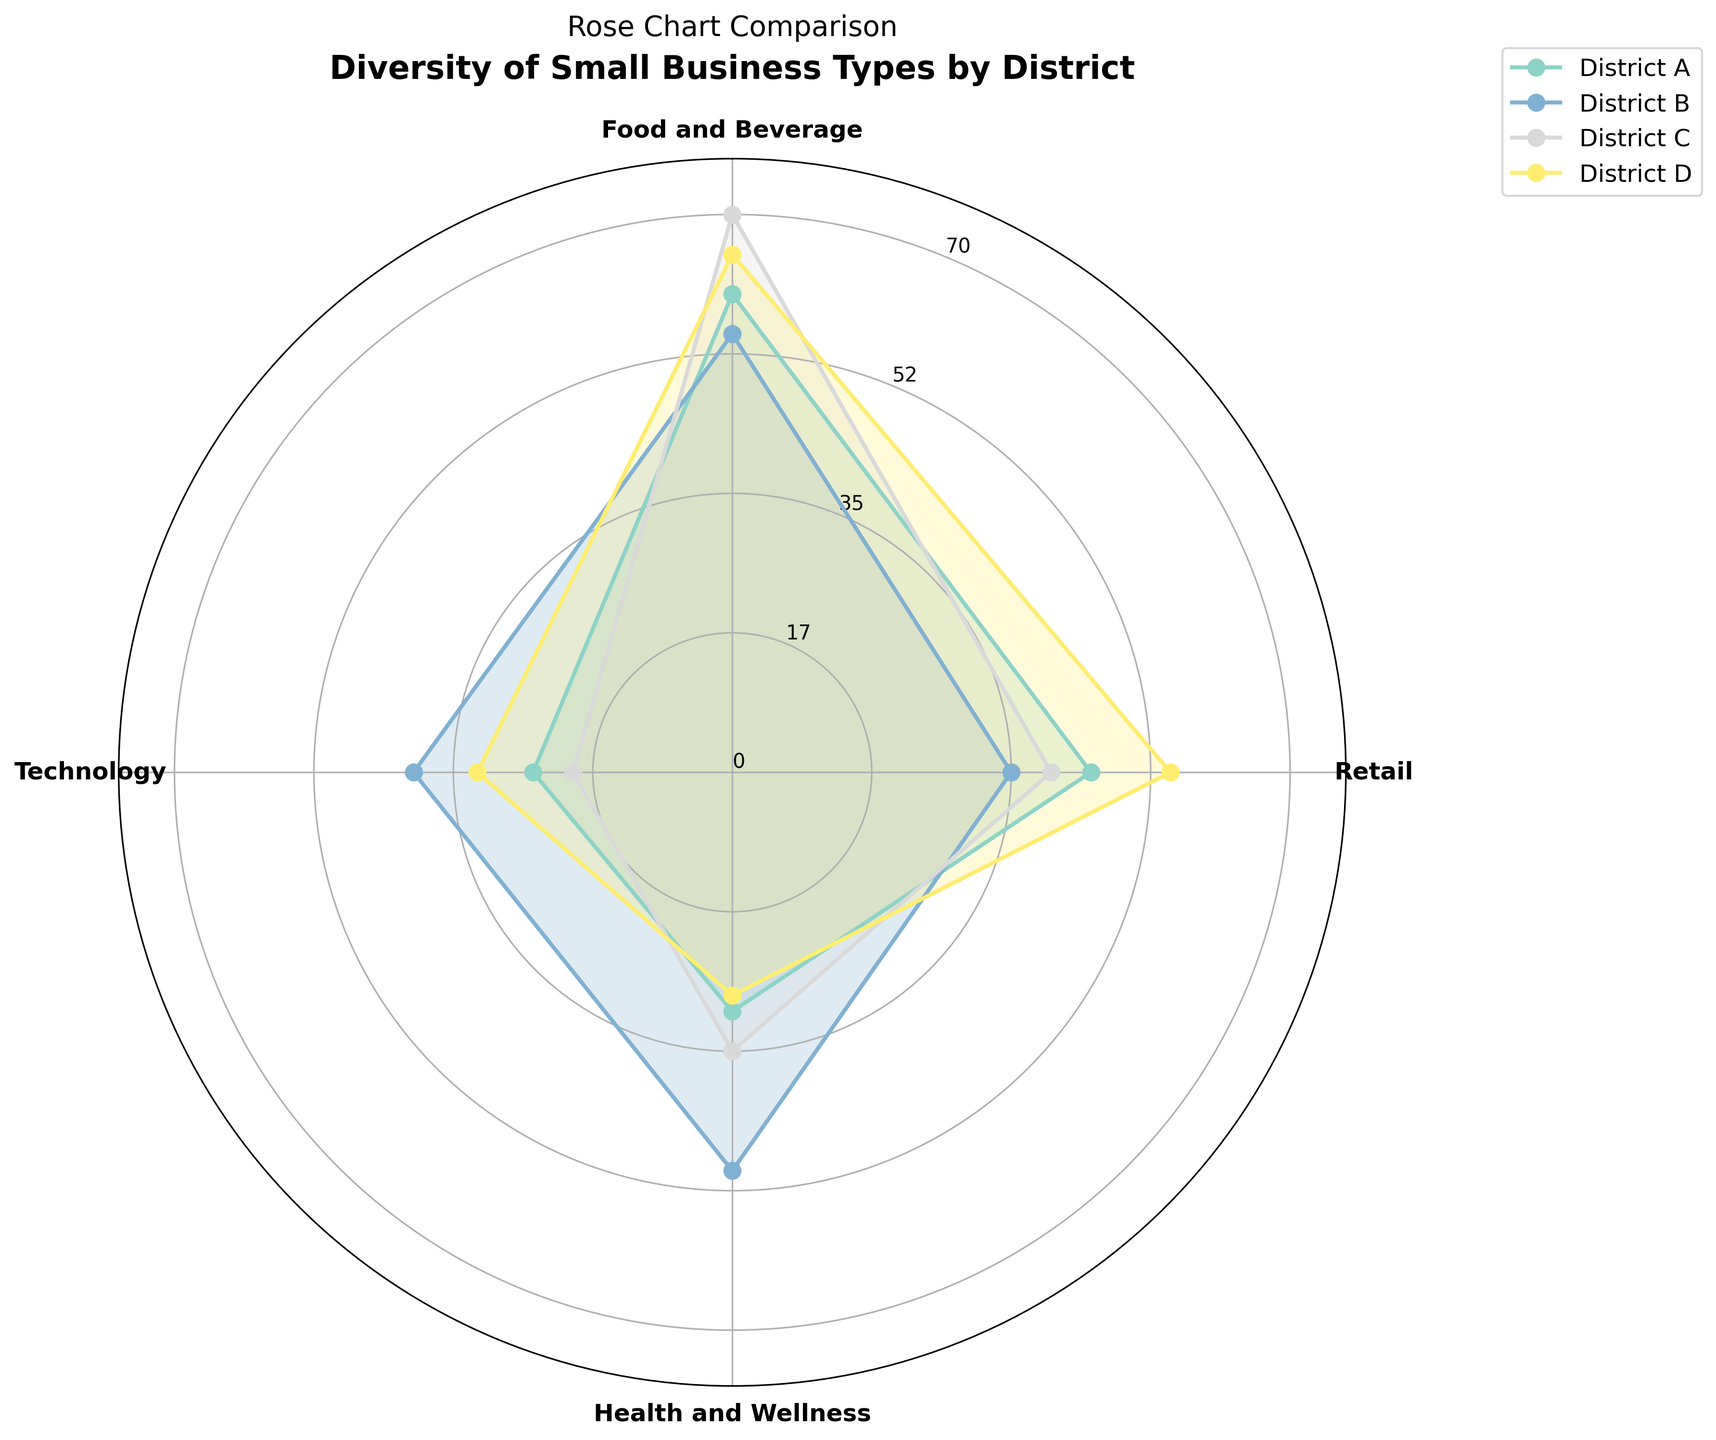What is the title of the chart? The title is typically located at the top of the chart and provides a summary of what the chart is about.
Answer: Diversity of Small Business Types by District Which district has the highest number of Food and Beverage small businesses? Look at the Food and Beverage section in the rose chart for all districts and identify the one with the longest bar.
Answer: District C How many categories of small businesses are represented in the chart? Count the distinct labels on the outer part of the rose chart, representing different categories.
Answer: Four Comparing District A and District D, which one has more Retail small businesses? Look at the Retail section in the rose chart for both District A and District D and compare the lengths of the bars.
Answer: District D What is the combined number of Health and Wellness small businesses in Districts A and B? Look at the Health and Wellness section for District A and District B, sum their values: 30 (A) + 50 (B).
Answer: 80 Which category has the least number of small businesses in District C? Look at the different sections for District C and find the one with the shortest bar.
Answer: Technology What is the difference between the number of Technology small businesses in District B and District D? Subtract the number of Technology small businesses in District B from that in District D: 32 (D) - 40 (B).
Answer: -8 Among all districts, which has the most balanced distribution across all small business categories? Look at the distribution of all categories in each district and identify the one where the lengths of the bars are most similar.
Answer: District B What is the average number of Retail small businesses across all districts? Calculate the sum of Retail small businesses in all districts and divide by the number of districts: (45 + 35 + 40 + 55) / 4.
Answer: 43.75 Which district has the highest total number of small businesses? Sum the values of all categories for each district and identify the one with the highest total.
Answer: District D 